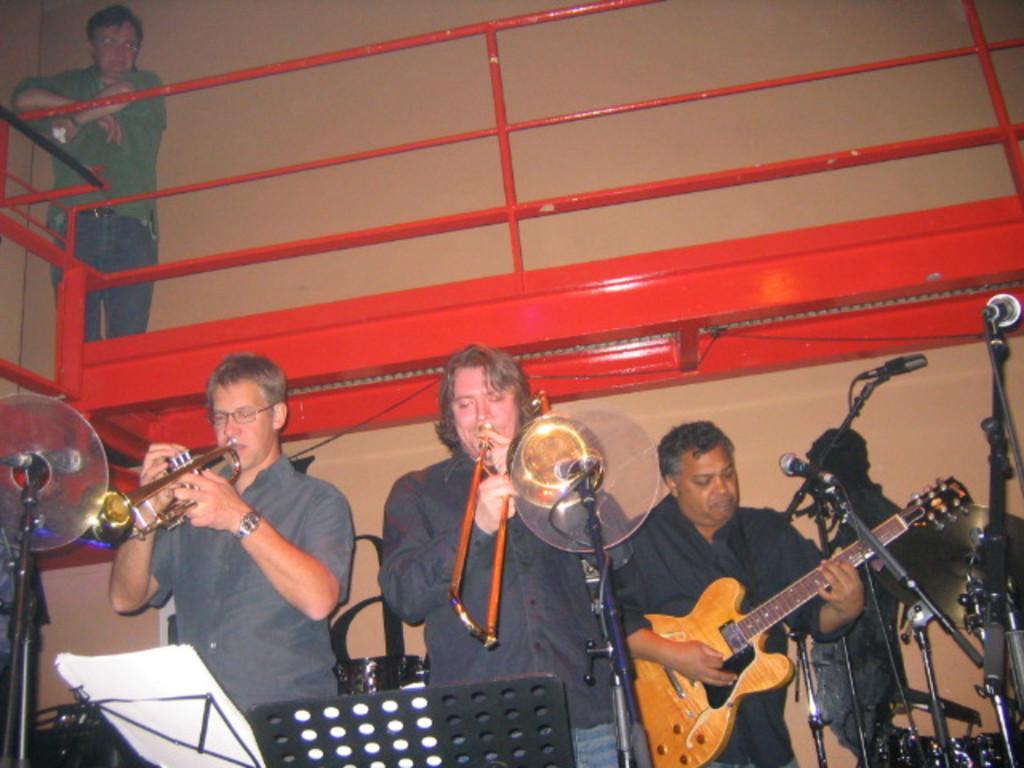Please provide a concise description of this image. In this image there are group of people who are standing. On the right side there is one person who is standing and he is holding a guitar. In the middle there is one person who is standing and he is holding a trumpet and beside him there is another person who is standing, and he is also holding a trumpet and in front of them there are mikes and boards are there and on the boards there are some papers. On the top there is wall and another person is standing and looking at them. 